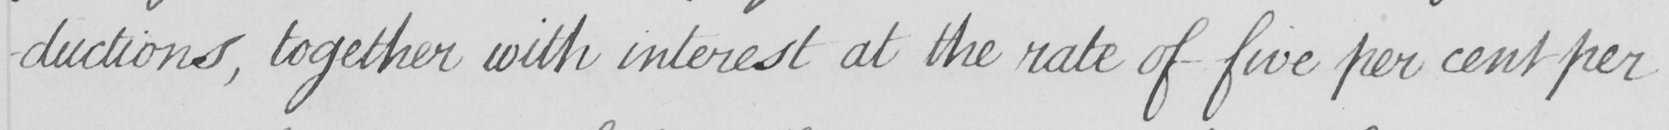Can you tell me what this handwritten text says? -ductions , together with interest at the rate of five per cent per 